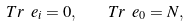<formula> <loc_0><loc_0><loc_500><loc_500>T r \ e _ { i } = 0 , \quad T r \ e _ { 0 } = N ,</formula> 